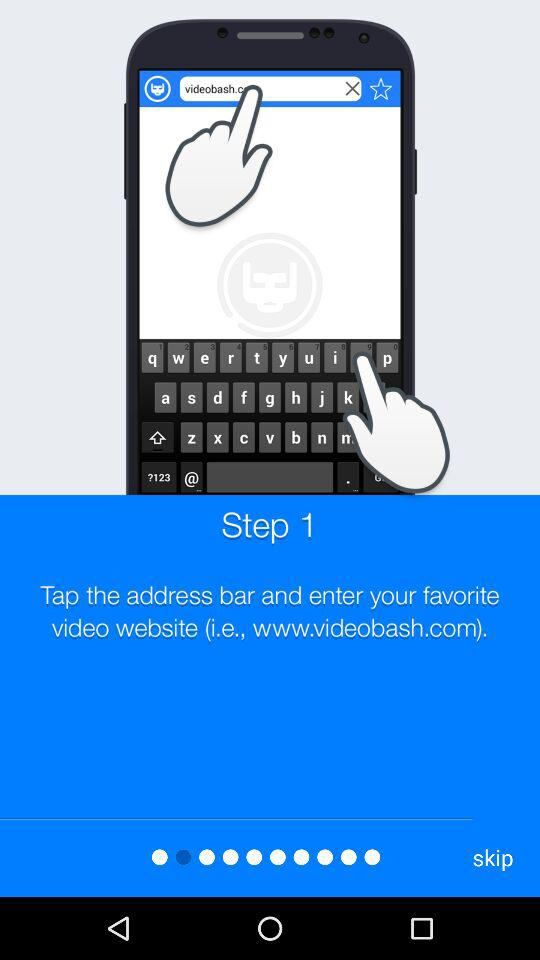What is the current step number? The current step number is 1. 